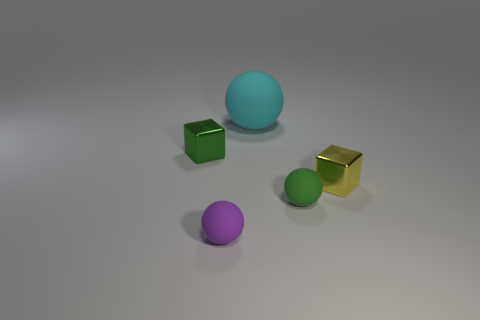Subtract all large matte balls. How many balls are left? 2 Subtract 1 balls. How many balls are left? 2 Add 5 small green metallic cubes. How many objects exist? 10 Subtract 0 red cylinders. How many objects are left? 5 Subtract all spheres. How many objects are left? 2 Subtract all small purple balls. Subtract all large cyan spheres. How many objects are left? 3 Add 1 green metallic blocks. How many green metallic blocks are left? 2 Add 4 tiny green cubes. How many tiny green cubes exist? 5 